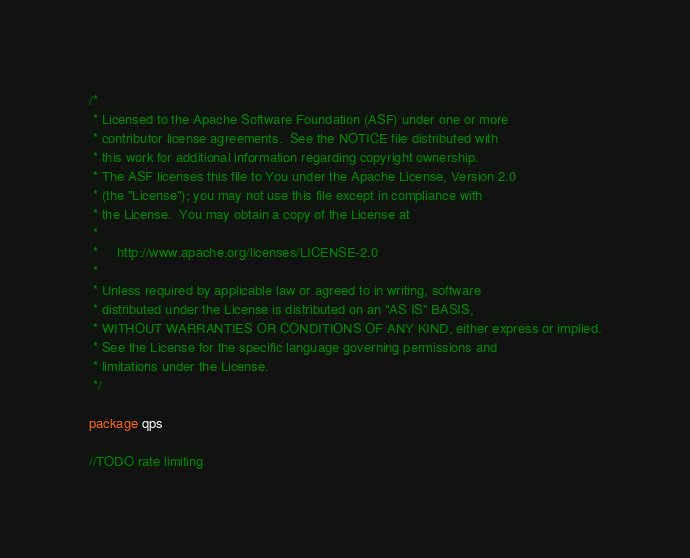Convert code to text. <code><loc_0><loc_0><loc_500><loc_500><_Go_>/*
 * Licensed to the Apache Software Foundation (ASF) under one or more
 * contributor license agreements.  See the NOTICE file distributed with
 * this work for additional information regarding copyright ownership.
 * The ASF licenses this file to You under the Apache License, Version 2.0
 * (the "License"); you may not use this file except in compliance with
 * the License.  You may obtain a copy of the License at
 *
 *     http://www.apache.org/licenses/LICENSE-2.0
 *
 * Unless required by applicable law or agreed to in writing, software
 * distributed under the License is distributed on an "AS IS" BASIS,
 * WITHOUT WARRANTIES OR CONDITIONS OF ANY KIND, either express or implied.
 * See the License for the specific language governing permissions and
 * limitations under the License.
 */

package qps

//TODO rate limiting
</code> 